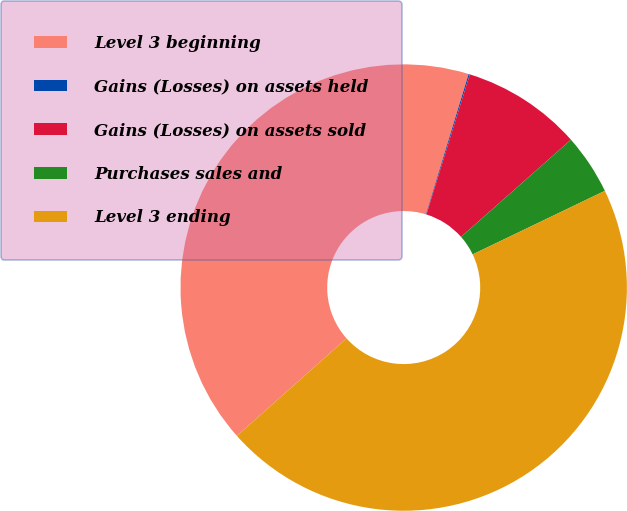Convert chart. <chart><loc_0><loc_0><loc_500><loc_500><pie_chart><fcel>Level 3 beginning<fcel>Gains (Losses) on assets held<fcel>Gains (Losses) on assets sold<fcel>Purchases sales and<fcel>Level 3 ending<nl><fcel>41.26%<fcel>0.09%<fcel>8.69%<fcel>4.39%<fcel>45.56%<nl></chart> 